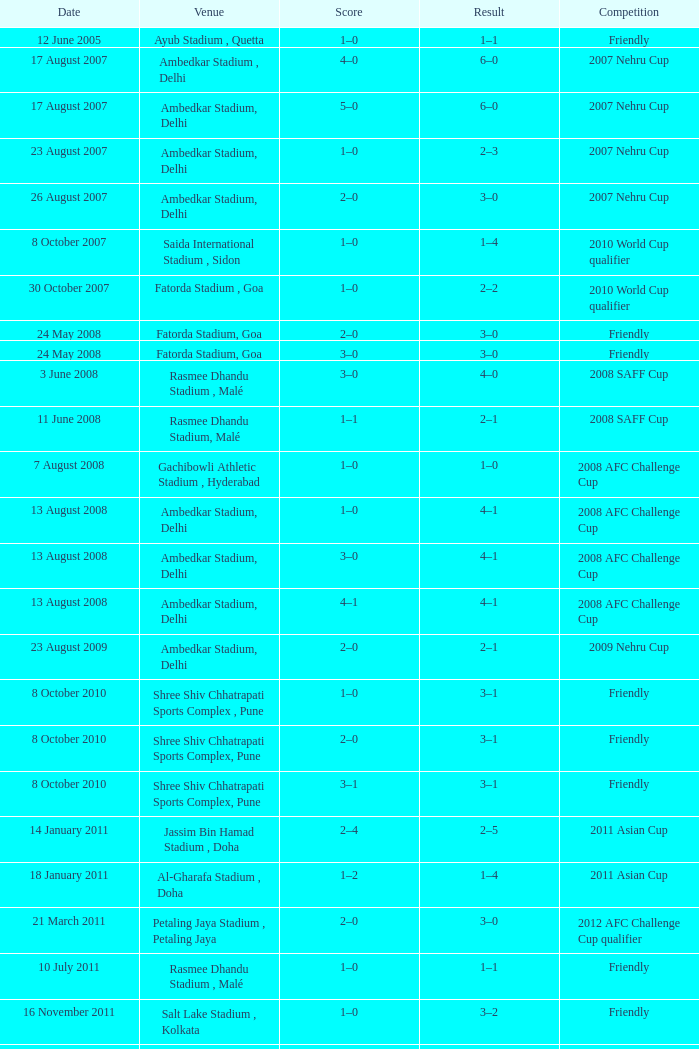Tell me the score on 22 august 2012 1–0. 